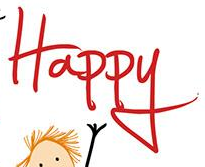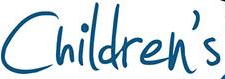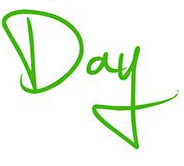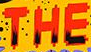What words are shown in these images in order, separated by a semicolon? Happy; Children's; Day; THE 